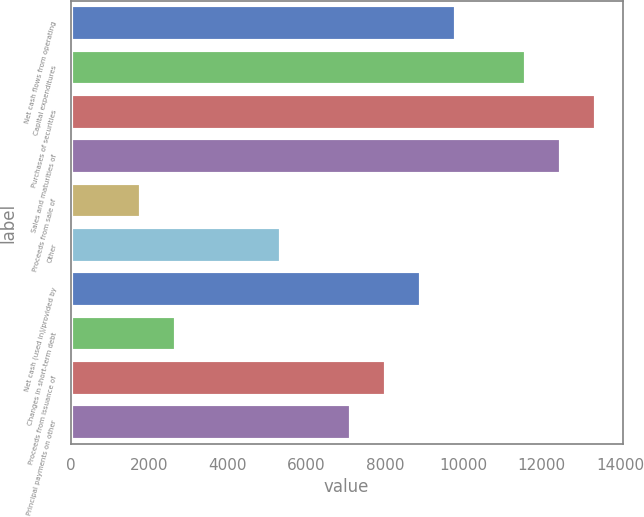Convert chart to OTSL. <chart><loc_0><loc_0><loc_500><loc_500><bar_chart><fcel>Net cash flows from operating<fcel>Capital expenditures<fcel>Purchases of securities<fcel>Sales and maturities of<fcel>Proceeds from sale of<fcel>Other<fcel>Net cash (used in)/provided by<fcel>Changes in short-term debt<fcel>Proceeds from issuance of<fcel>Principal payments on other<nl><fcel>9817.1<fcel>11601.3<fcel>13385.5<fcel>12493.4<fcel>1788.2<fcel>5356.6<fcel>8925<fcel>2680.3<fcel>8032.9<fcel>7140.8<nl></chart> 